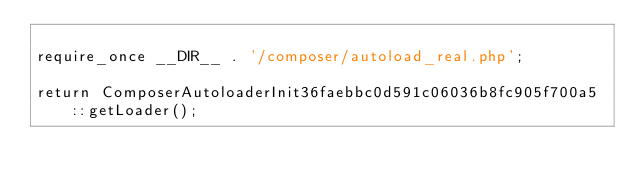Convert code to text. <code><loc_0><loc_0><loc_500><loc_500><_PHP_>
require_once __DIR__ . '/composer/autoload_real.php';

return ComposerAutoloaderInit36faebbc0d591c06036b8fc905f700a5::getLoader();
</code> 